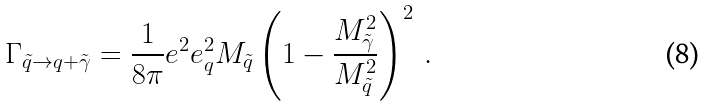Convert formula to latex. <formula><loc_0><loc_0><loc_500><loc_500>\Gamma _ { \tilde { q } \rightarrow q + \tilde { \gamma } } = \frac { 1 } { 8 \pi } e ^ { 2 } e _ { q } ^ { 2 } M _ { \tilde { q } } \left ( 1 - \frac { M ^ { 2 } _ { \tilde { \gamma } } } { M ^ { 2 } _ { \tilde { q } } } \right ) ^ { 2 } \, .</formula> 